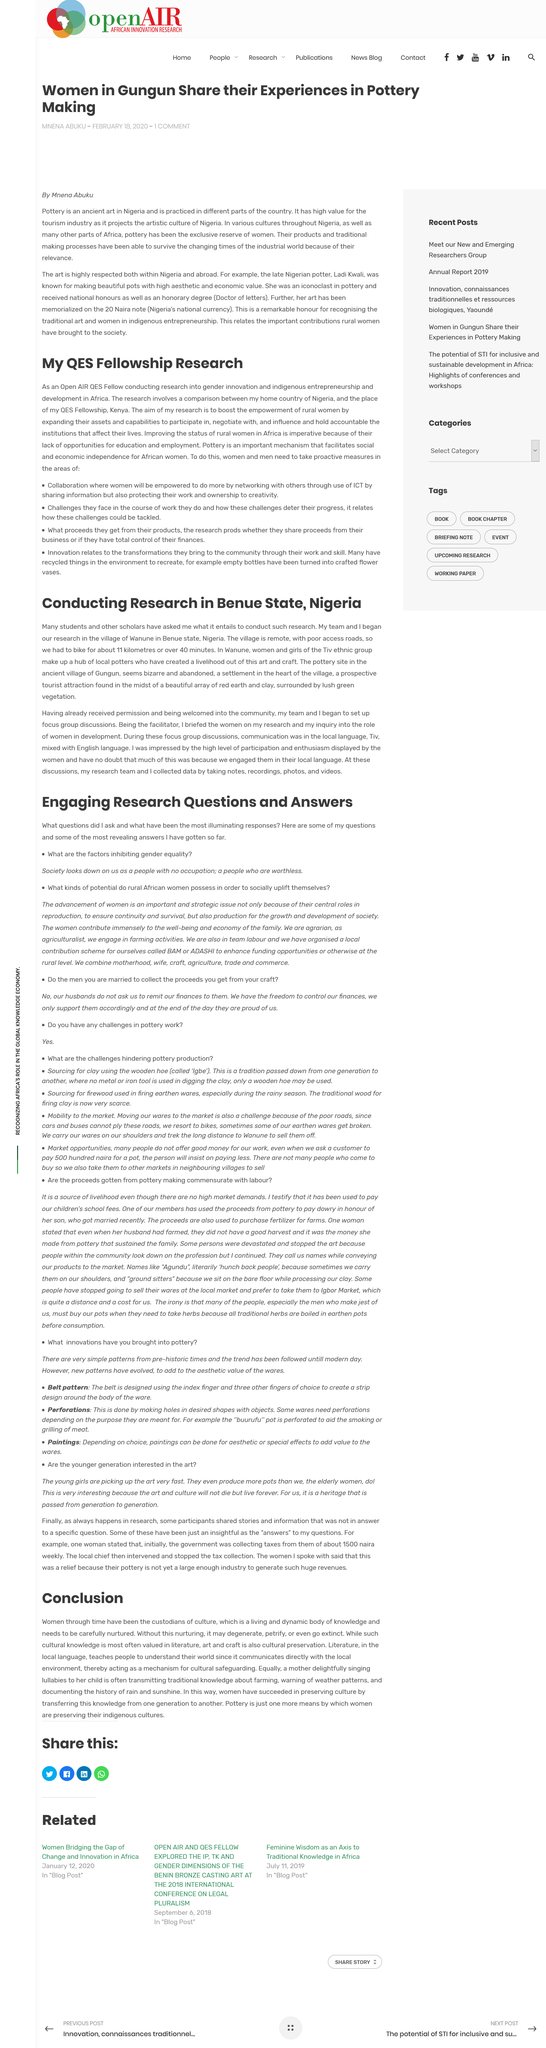Mention a couple of crucial points in this snapshot. The pottery site in Benue State, Nigeria, is used for research in the ancient village of Gungun. I am conducting research on gender innovation and indigenous entrepreneurship and development in Africa as an Open AIR QES Fellow. The women and girls of the Tiv ethnic group are skilled artisans who create beautiful and functional pottery. Pottery is a means by which women are preserving their indigenous cultures, and it is an essential aspect of many indigenous communities around the world. The researchers had to bike a total of 11 kilometres to reach the remote village of Wanune. 